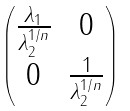<formula> <loc_0><loc_0><loc_500><loc_500>\begin{pmatrix} \frac { \lambda _ { 1 } } { \lambda _ { 2 } ^ { 1 / n } } & 0 \\ 0 & \frac { 1 } { \lambda _ { 2 } ^ { 1 / n } } \end{pmatrix}</formula> 